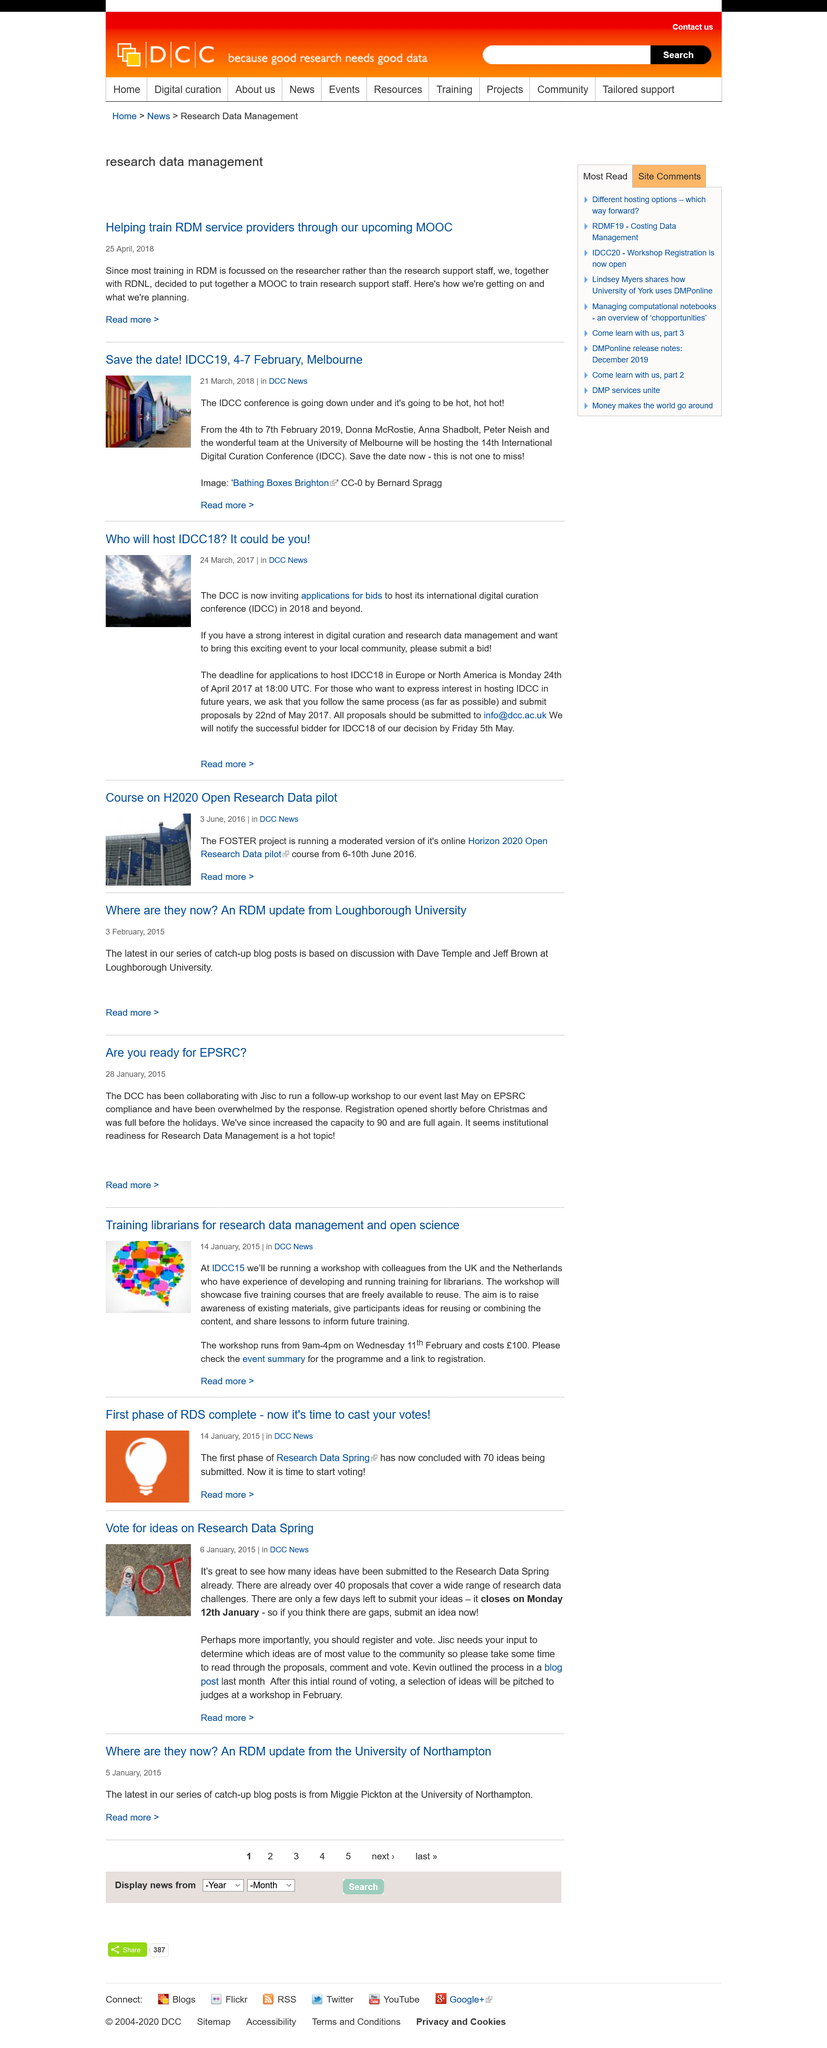List a handful of essential elements in this visual. The article on the completion of the first phase of RDS was published on 14th January, 2015. The workshop to be held at IDCC15 will cost £100. The article on the first phase of RDS being complete falls under the DCC News category. 